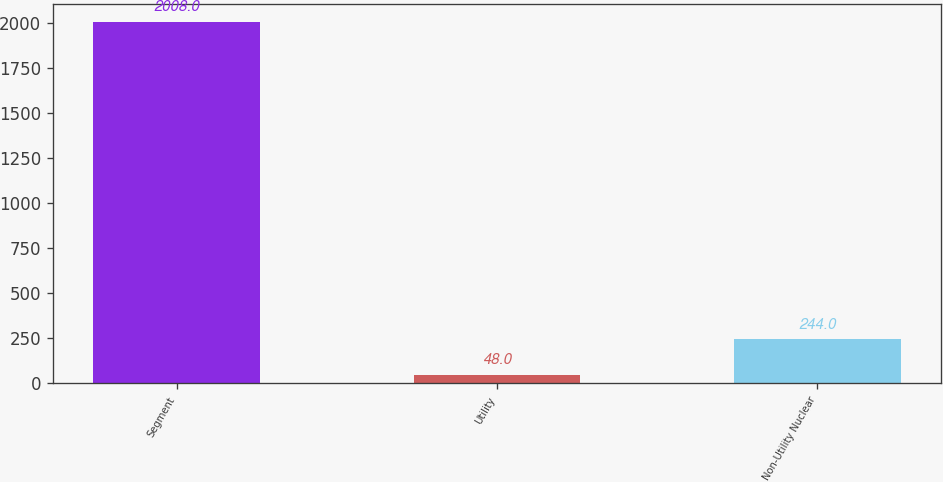Convert chart. <chart><loc_0><loc_0><loc_500><loc_500><bar_chart><fcel>Segment<fcel>Utility<fcel>Non-Utility Nuclear<nl><fcel>2008<fcel>48<fcel>244<nl></chart> 